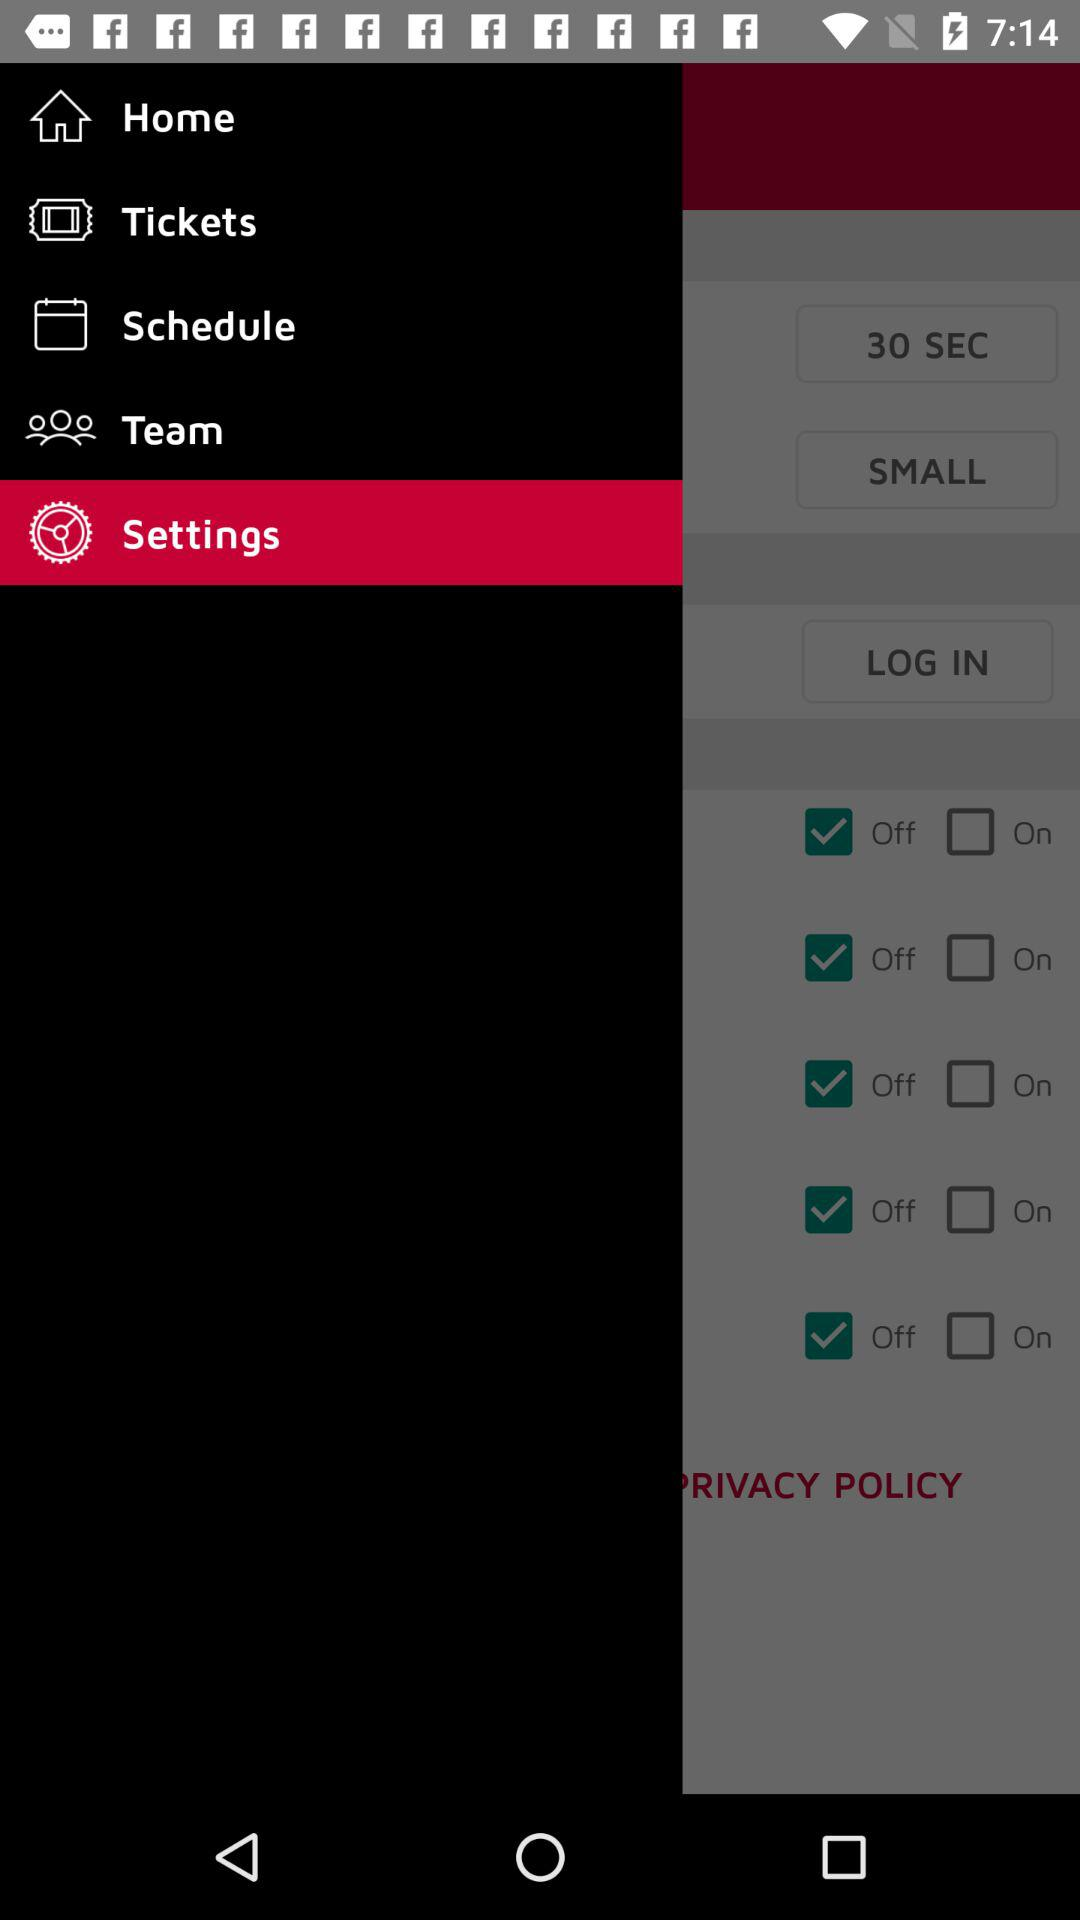Which item is selected in the menu? The selected item is "Settings". 